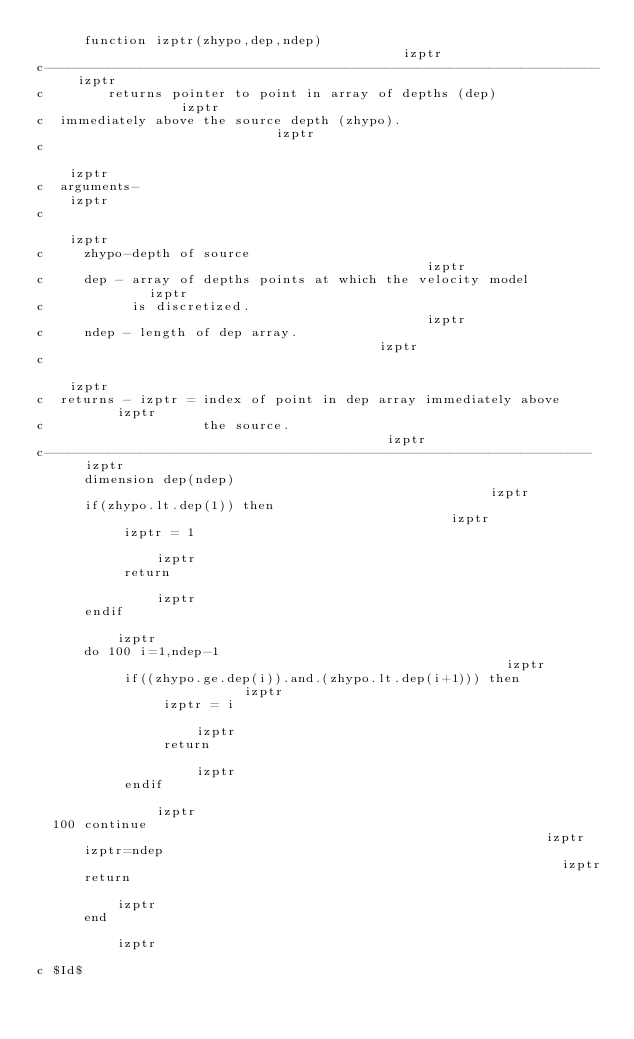<code> <loc_0><loc_0><loc_500><loc_500><_FORTRAN_>      function izptr(zhypo,dep,ndep)                                     izptr
c----------------------------------------------------------------------  izptr
c        returns pointer to point in array of depths (dep)               izptr
c  immediately above the source depth (zhypo).                           izptr
c                                                                        izptr
c  arguments-                                                           izptr 
c                                                                        izptr
c     zhypo-depth of source                                              izptr
c     dep - array of depths points at which the velocity model           izptr
c           is discretized.                                              izptr
c     ndep - length of dep array.                                        izptr
c                                                                        izptr
c  returns - izptr = index of point in dep array immediately above       izptr
c                    the source.                                         izptr
c---------------------------------------------------------------------   izptr
      dimension dep(ndep)                                                izptr
      if(zhypo.lt.dep(1)) then                                           izptr
           izptr = 1                                                     izptr
           return                                                        izptr
      endif                                                              izptr
      do 100 i=1,ndep-1                                                  izptr
           if((zhypo.ge.dep(i)).and.(zhypo.lt.dep(i+1))) then            izptr
                izptr = i                                                izptr
                return                                                   izptr
           endif                                                         izptr
  100 continue                                                           izptr
      izptr=ndep                                                         izptr
      return                                                             izptr
      end                                                                izptr

c $Id$ 
</code> 